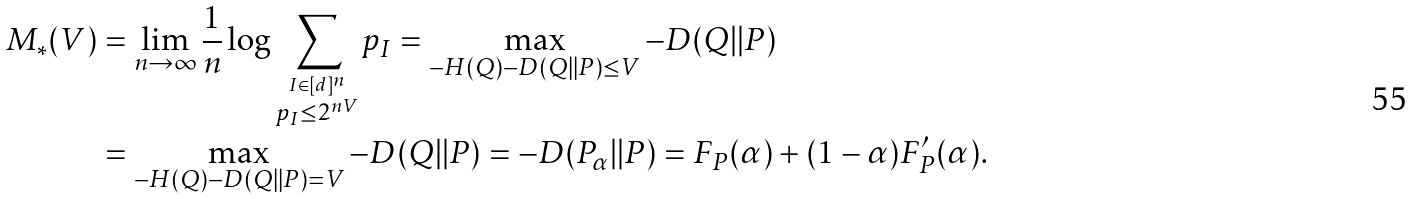<formula> <loc_0><loc_0><loc_500><loc_500>M _ { * } ( V ) & = \lim _ { n \to \infty } \frac { 1 } { n } \log \sum _ { \stackrel { I \in [ d ] ^ { n } } { p _ { I } \leq 2 ^ { n V } } } p _ { I } = \max _ { - H ( Q ) - D ( Q | | P ) \leq V } - D ( Q | | P ) \\ & = \max _ { - H ( Q ) - D ( Q | | P ) = V } - D ( Q | | P ) = - D ( P _ { \alpha } | | P ) = F _ { P } ( \alpha ) + ( 1 - \alpha ) F _ { P } ^ { \prime } ( \alpha ) .</formula> 